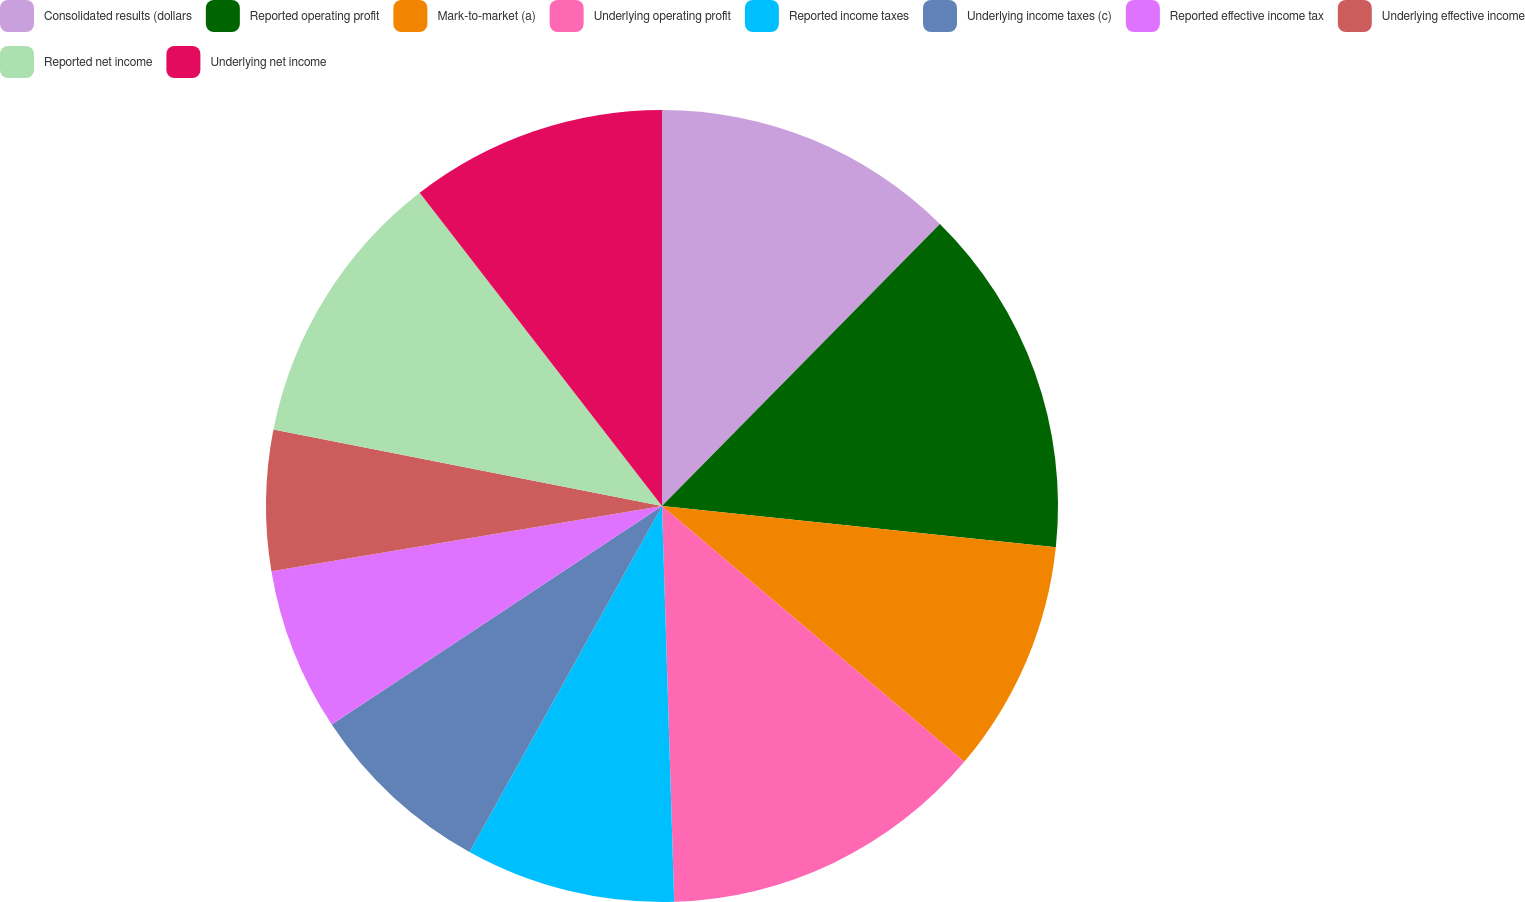<chart> <loc_0><loc_0><loc_500><loc_500><pie_chart><fcel>Consolidated results (dollars<fcel>Reported operating profit<fcel>Mark-to-market (a)<fcel>Underlying operating profit<fcel>Reported income taxes<fcel>Underlying income taxes (c)<fcel>Reported effective income tax<fcel>Underlying effective income<fcel>Reported net income<fcel>Underlying net income<nl><fcel>12.38%<fcel>14.28%<fcel>9.52%<fcel>13.33%<fcel>8.57%<fcel>7.62%<fcel>6.67%<fcel>5.72%<fcel>11.43%<fcel>10.48%<nl></chart> 